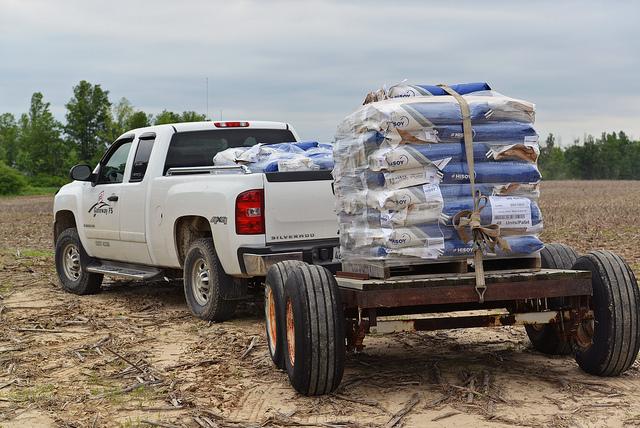What is the truck sitting on?
Short answer required. Dirt. What season is it in the photo?
Give a very brief answer. Spring. What is the truck moving?
Concise answer only. Soil. Is this photo probably taken in the United States?
Answer briefly. Yes. What kind of truck is this?
Short answer required. Pickup. Is the truck independent or owned by a business?
Be succinct. Business. What is being towed?
Quick response, please. Trailer. What is pictured on the door of the truck?
Be succinct. Logo. What is on top of the truck?
Be succinct. Bags. 